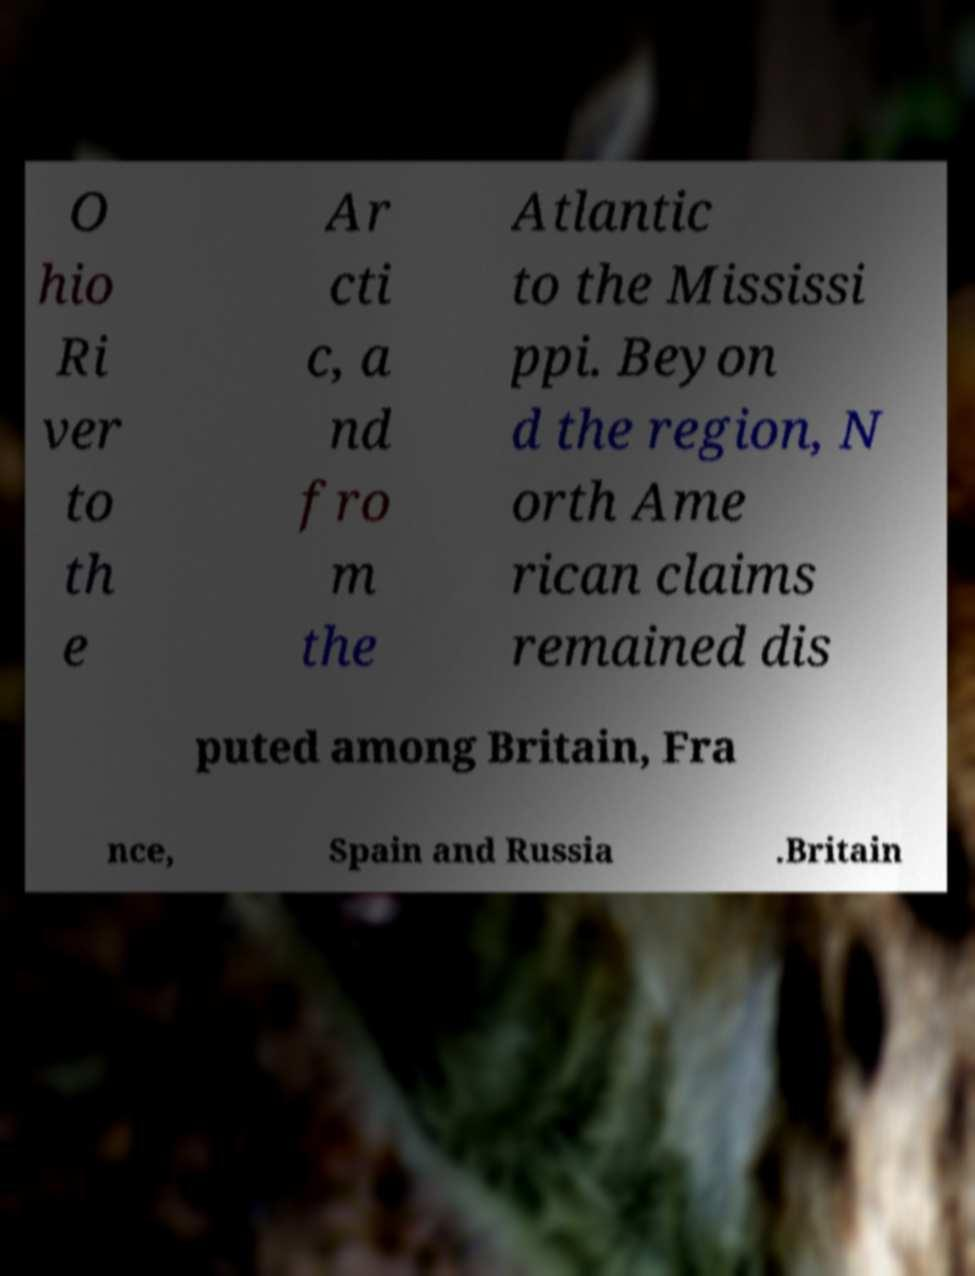Can you accurately transcribe the text from the provided image for me? O hio Ri ver to th e Ar cti c, a nd fro m the Atlantic to the Mississi ppi. Beyon d the region, N orth Ame rican claims remained dis puted among Britain, Fra nce, Spain and Russia .Britain 